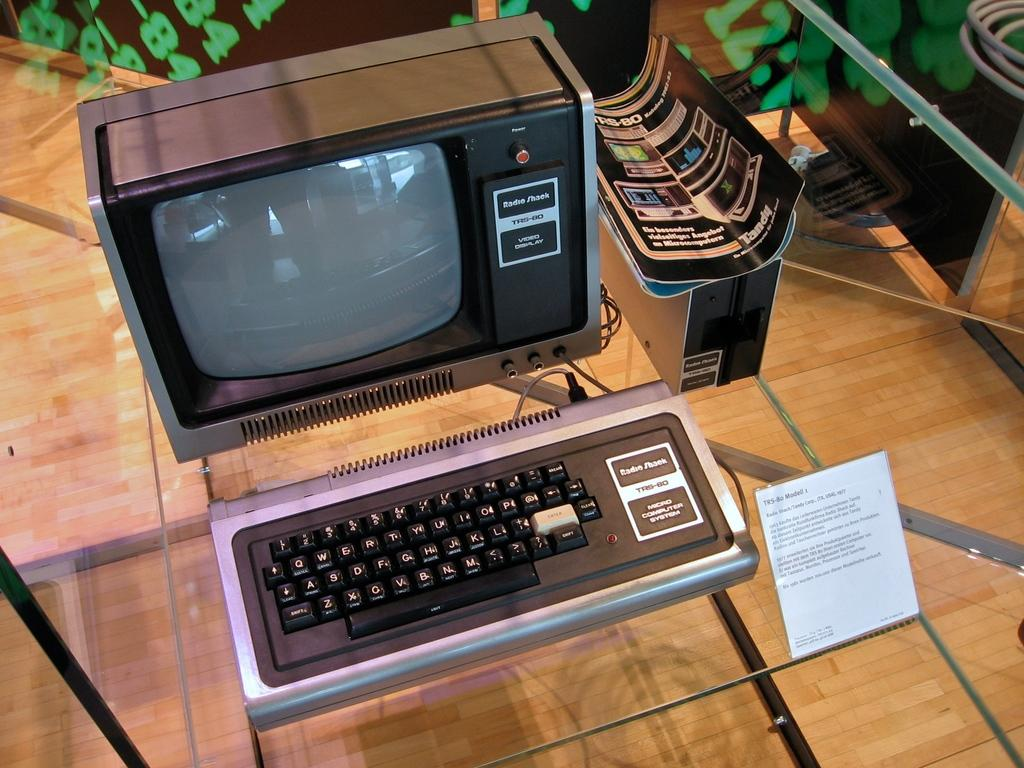What is the main object on the glass table in the image? There is a system on a glass table in the image. What is placed in front of the system? There is a board in front of the system. What is placed on top of the CPU? There are pamphlets on the CPU. What type of flooring is visible in the image? The floor is made of wood. What is the temperature of the hot thought in the image? There is no mention of a hot thought in the image; the facts provided do not include any reference to thoughts or temperature. 